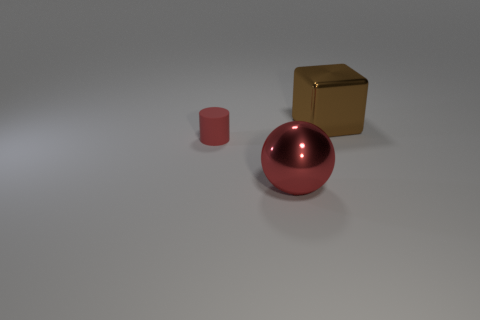Is there anything else that has the same material as the tiny red cylinder?
Your answer should be compact. No. The small matte thing that is the same color as the sphere is what shape?
Provide a succinct answer. Cylinder. There is a red thing that is behind the red object on the right side of the rubber cylinder; how big is it?
Your response must be concise. Small. There is a red thing that is to the left of the large ball; is its shape the same as the metallic object that is in front of the brown shiny thing?
Provide a succinct answer. No. Are there the same number of objects behind the tiny red rubber cylinder and blocks?
Ensure brevity in your answer.  Yes. Is the thing behind the matte cylinder made of the same material as the big red object?
Provide a succinct answer. Yes. How many big objects are red balls or brown objects?
Provide a succinct answer. 2. What is the size of the red ball?
Give a very brief answer. Large. There is a brown metallic cube; does it have the same size as the shiny ball that is to the left of the large brown metallic object?
Your answer should be very brief. Yes. How many purple objects are large objects or rubber cylinders?
Your answer should be compact. 0. 